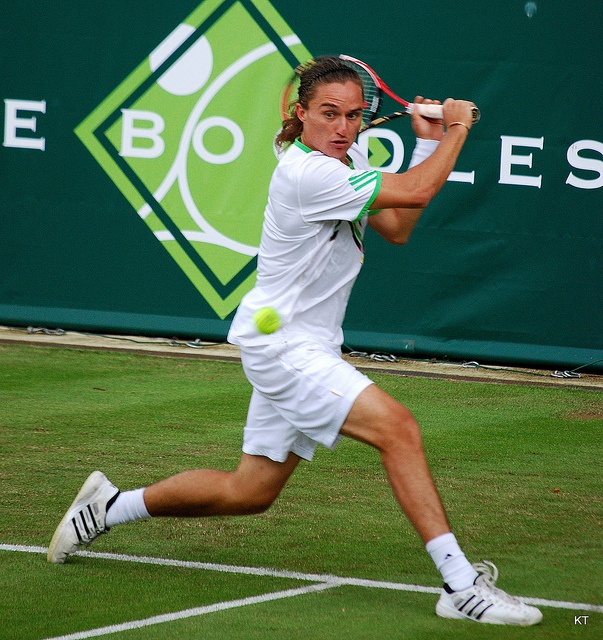Describe the objects in this image and their specific colors. I can see people in black, lavender, salmon, and darkgray tones, tennis racket in black, olive, lightgray, and teal tones, and sports ball in black, lightgreen, and khaki tones in this image. 